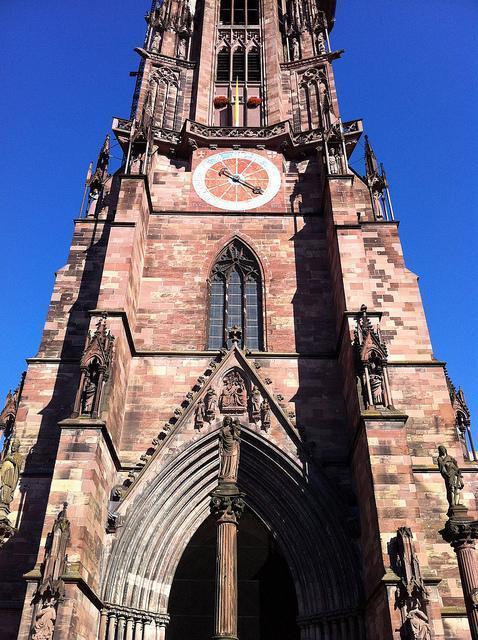How many animals have a bird on their back?
Give a very brief answer. 0. 